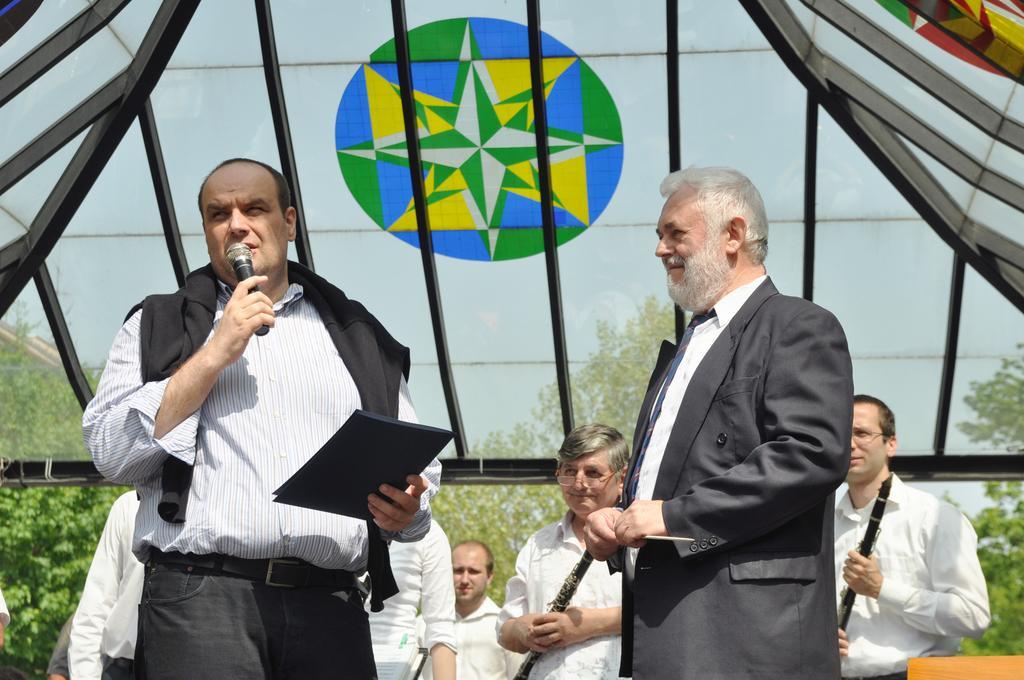Could you give a brief overview of what you see in this image? In this image I can see some people. In the background, I can see the trees and the sky. 